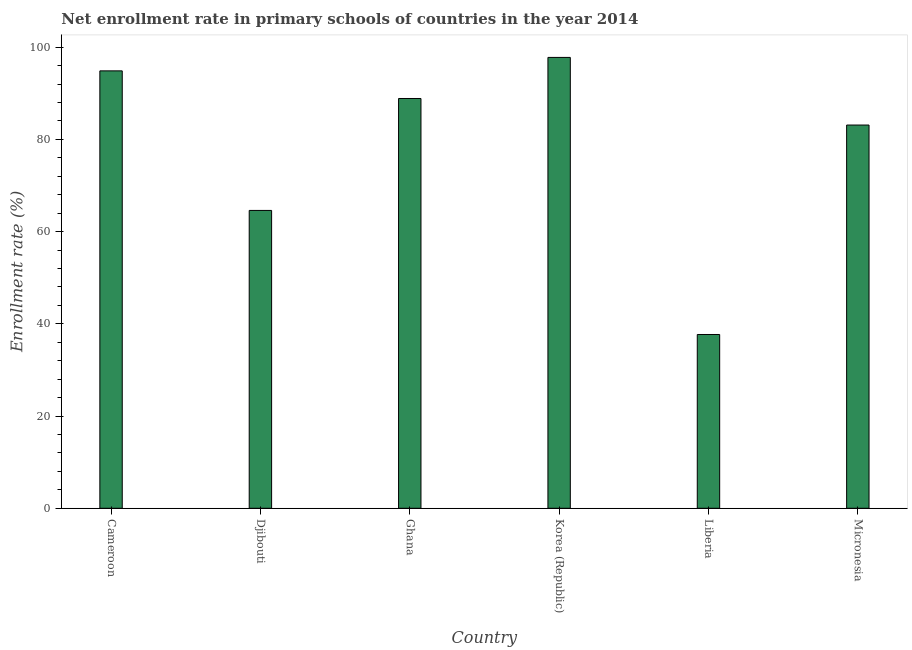Does the graph contain any zero values?
Your answer should be compact. No. What is the title of the graph?
Provide a short and direct response. Net enrollment rate in primary schools of countries in the year 2014. What is the label or title of the X-axis?
Offer a very short reply. Country. What is the label or title of the Y-axis?
Your response must be concise. Enrollment rate (%). What is the net enrollment rate in primary schools in Korea (Republic)?
Your answer should be very brief. 97.79. Across all countries, what is the maximum net enrollment rate in primary schools?
Offer a very short reply. 97.79. Across all countries, what is the minimum net enrollment rate in primary schools?
Make the answer very short. 37.69. In which country was the net enrollment rate in primary schools maximum?
Provide a succinct answer. Korea (Republic). In which country was the net enrollment rate in primary schools minimum?
Keep it short and to the point. Liberia. What is the sum of the net enrollment rate in primary schools?
Provide a short and direct response. 466.94. What is the difference between the net enrollment rate in primary schools in Cameroon and Liberia?
Offer a very short reply. 57.18. What is the average net enrollment rate in primary schools per country?
Give a very brief answer. 77.82. What is the median net enrollment rate in primary schools?
Your response must be concise. 86. What is the ratio of the net enrollment rate in primary schools in Ghana to that in Micronesia?
Provide a short and direct response. 1.07. What is the difference between the highest and the second highest net enrollment rate in primary schools?
Your answer should be compact. 2.92. What is the difference between the highest and the lowest net enrollment rate in primary schools?
Your answer should be compact. 60.1. In how many countries, is the net enrollment rate in primary schools greater than the average net enrollment rate in primary schools taken over all countries?
Provide a succinct answer. 4. How many bars are there?
Offer a terse response. 6. Are all the bars in the graph horizontal?
Give a very brief answer. No. How many countries are there in the graph?
Offer a terse response. 6. What is the difference between two consecutive major ticks on the Y-axis?
Your response must be concise. 20. What is the Enrollment rate (%) in Cameroon?
Give a very brief answer. 94.87. What is the Enrollment rate (%) of Djibouti?
Your answer should be very brief. 64.6. What is the Enrollment rate (%) of Ghana?
Provide a short and direct response. 88.88. What is the Enrollment rate (%) of Korea (Republic)?
Make the answer very short. 97.79. What is the Enrollment rate (%) in Liberia?
Ensure brevity in your answer.  37.69. What is the Enrollment rate (%) of Micronesia?
Ensure brevity in your answer.  83.12. What is the difference between the Enrollment rate (%) in Cameroon and Djibouti?
Provide a succinct answer. 30.27. What is the difference between the Enrollment rate (%) in Cameroon and Ghana?
Provide a short and direct response. 5.99. What is the difference between the Enrollment rate (%) in Cameroon and Korea (Republic)?
Give a very brief answer. -2.92. What is the difference between the Enrollment rate (%) in Cameroon and Liberia?
Your answer should be compact. 57.18. What is the difference between the Enrollment rate (%) in Cameroon and Micronesia?
Your response must be concise. 11.75. What is the difference between the Enrollment rate (%) in Djibouti and Ghana?
Your answer should be compact. -24.28. What is the difference between the Enrollment rate (%) in Djibouti and Korea (Republic)?
Your answer should be compact. -33.19. What is the difference between the Enrollment rate (%) in Djibouti and Liberia?
Ensure brevity in your answer.  26.91. What is the difference between the Enrollment rate (%) in Djibouti and Micronesia?
Give a very brief answer. -18.52. What is the difference between the Enrollment rate (%) in Ghana and Korea (Republic)?
Give a very brief answer. -8.91. What is the difference between the Enrollment rate (%) in Ghana and Liberia?
Your answer should be very brief. 51.19. What is the difference between the Enrollment rate (%) in Ghana and Micronesia?
Provide a succinct answer. 5.76. What is the difference between the Enrollment rate (%) in Korea (Republic) and Liberia?
Offer a terse response. 60.1. What is the difference between the Enrollment rate (%) in Korea (Republic) and Micronesia?
Provide a succinct answer. 14.67. What is the difference between the Enrollment rate (%) in Liberia and Micronesia?
Offer a terse response. -45.43. What is the ratio of the Enrollment rate (%) in Cameroon to that in Djibouti?
Provide a short and direct response. 1.47. What is the ratio of the Enrollment rate (%) in Cameroon to that in Ghana?
Your answer should be very brief. 1.07. What is the ratio of the Enrollment rate (%) in Cameroon to that in Liberia?
Offer a very short reply. 2.52. What is the ratio of the Enrollment rate (%) in Cameroon to that in Micronesia?
Your answer should be very brief. 1.14. What is the ratio of the Enrollment rate (%) in Djibouti to that in Ghana?
Provide a succinct answer. 0.73. What is the ratio of the Enrollment rate (%) in Djibouti to that in Korea (Republic)?
Offer a terse response. 0.66. What is the ratio of the Enrollment rate (%) in Djibouti to that in Liberia?
Your response must be concise. 1.71. What is the ratio of the Enrollment rate (%) in Djibouti to that in Micronesia?
Your response must be concise. 0.78. What is the ratio of the Enrollment rate (%) in Ghana to that in Korea (Republic)?
Offer a very short reply. 0.91. What is the ratio of the Enrollment rate (%) in Ghana to that in Liberia?
Your response must be concise. 2.36. What is the ratio of the Enrollment rate (%) in Ghana to that in Micronesia?
Offer a terse response. 1.07. What is the ratio of the Enrollment rate (%) in Korea (Republic) to that in Liberia?
Your answer should be very brief. 2.59. What is the ratio of the Enrollment rate (%) in Korea (Republic) to that in Micronesia?
Offer a very short reply. 1.18. What is the ratio of the Enrollment rate (%) in Liberia to that in Micronesia?
Offer a very short reply. 0.45. 